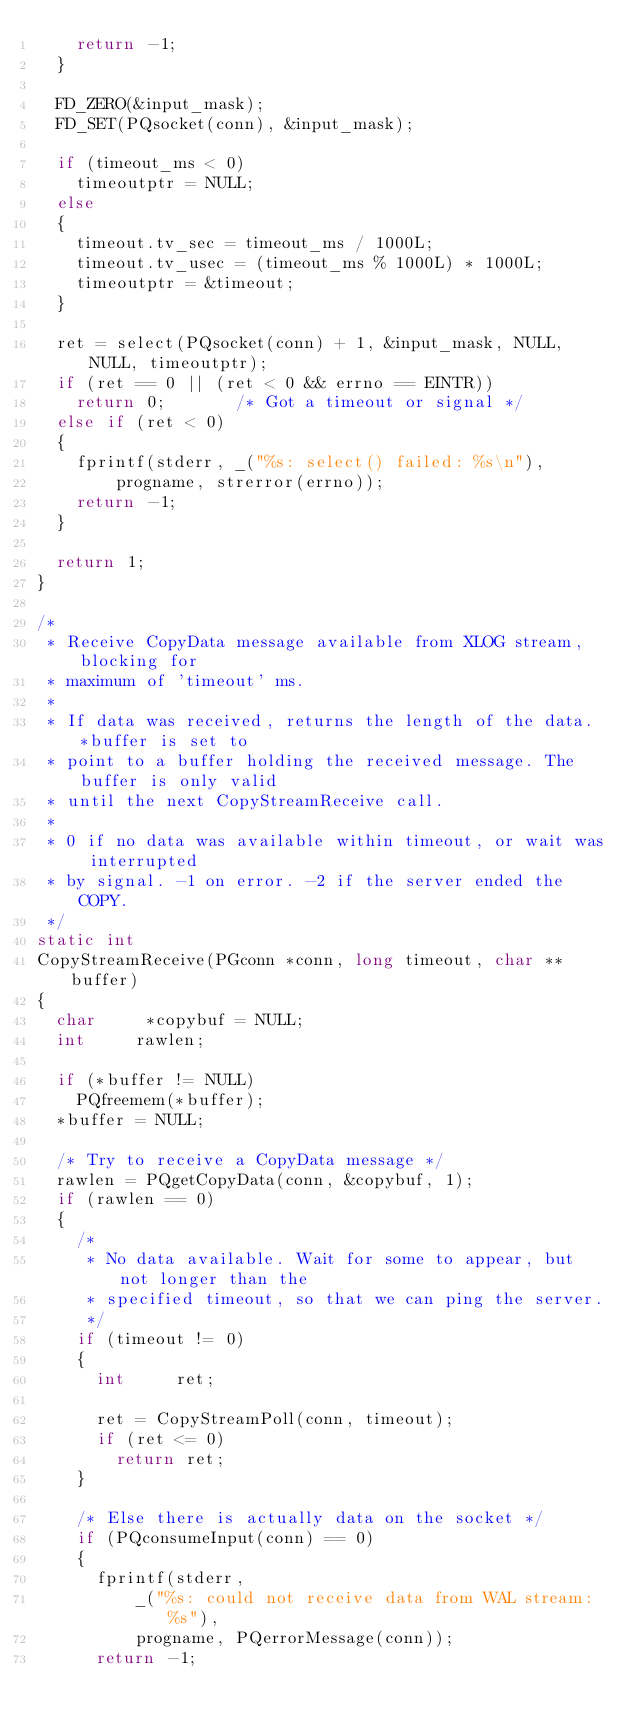Convert code to text. <code><loc_0><loc_0><loc_500><loc_500><_C_>		return -1;
	}

	FD_ZERO(&input_mask);
	FD_SET(PQsocket(conn), &input_mask);

	if (timeout_ms < 0)
		timeoutptr = NULL;
	else
	{
		timeout.tv_sec = timeout_ms / 1000L;
		timeout.tv_usec = (timeout_ms % 1000L) * 1000L;
		timeoutptr = &timeout;
	}

	ret = select(PQsocket(conn) + 1, &input_mask, NULL, NULL, timeoutptr);
	if (ret == 0 || (ret < 0 && errno == EINTR))
		return 0;				/* Got a timeout or signal */
	else if (ret < 0)
	{
		fprintf(stderr, _("%s: select() failed: %s\n"),
				progname, strerror(errno));
		return -1;
	}

	return 1;
}

/*
 * Receive CopyData message available from XLOG stream, blocking for
 * maximum of 'timeout' ms.
 *
 * If data was received, returns the length of the data. *buffer is set to
 * point to a buffer holding the received message. The buffer is only valid
 * until the next CopyStreamReceive call.
 *
 * 0 if no data was available within timeout, or wait was interrupted
 * by signal. -1 on error. -2 if the server ended the COPY.
 */
static int
CopyStreamReceive(PGconn *conn, long timeout, char **buffer)
{
	char	   *copybuf = NULL;
	int			rawlen;

	if (*buffer != NULL)
		PQfreemem(*buffer);
	*buffer = NULL;

	/* Try to receive a CopyData message */
	rawlen = PQgetCopyData(conn, &copybuf, 1);
	if (rawlen == 0)
	{
		/*
		 * No data available. Wait for some to appear, but not longer than the
		 * specified timeout, so that we can ping the server.
		 */
		if (timeout != 0)
		{
			int			ret;

			ret = CopyStreamPoll(conn, timeout);
			if (ret <= 0)
				return ret;
		}

		/* Else there is actually data on the socket */
		if (PQconsumeInput(conn) == 0)
		{
			fprintf(stderr,
					_("%s: could not receive data from WAL stream: %s"),
					progname, PQerrorMessage(conn));
			return -1;</code> 